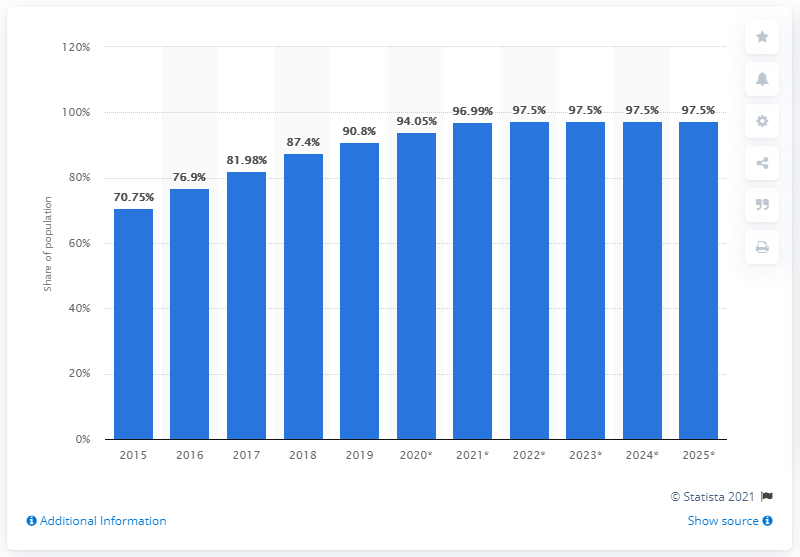Highlight a few significant elements in this photo. According to projections, the internet penetration rate in Malaysia is expected to grow to 97.5% by 2025. 